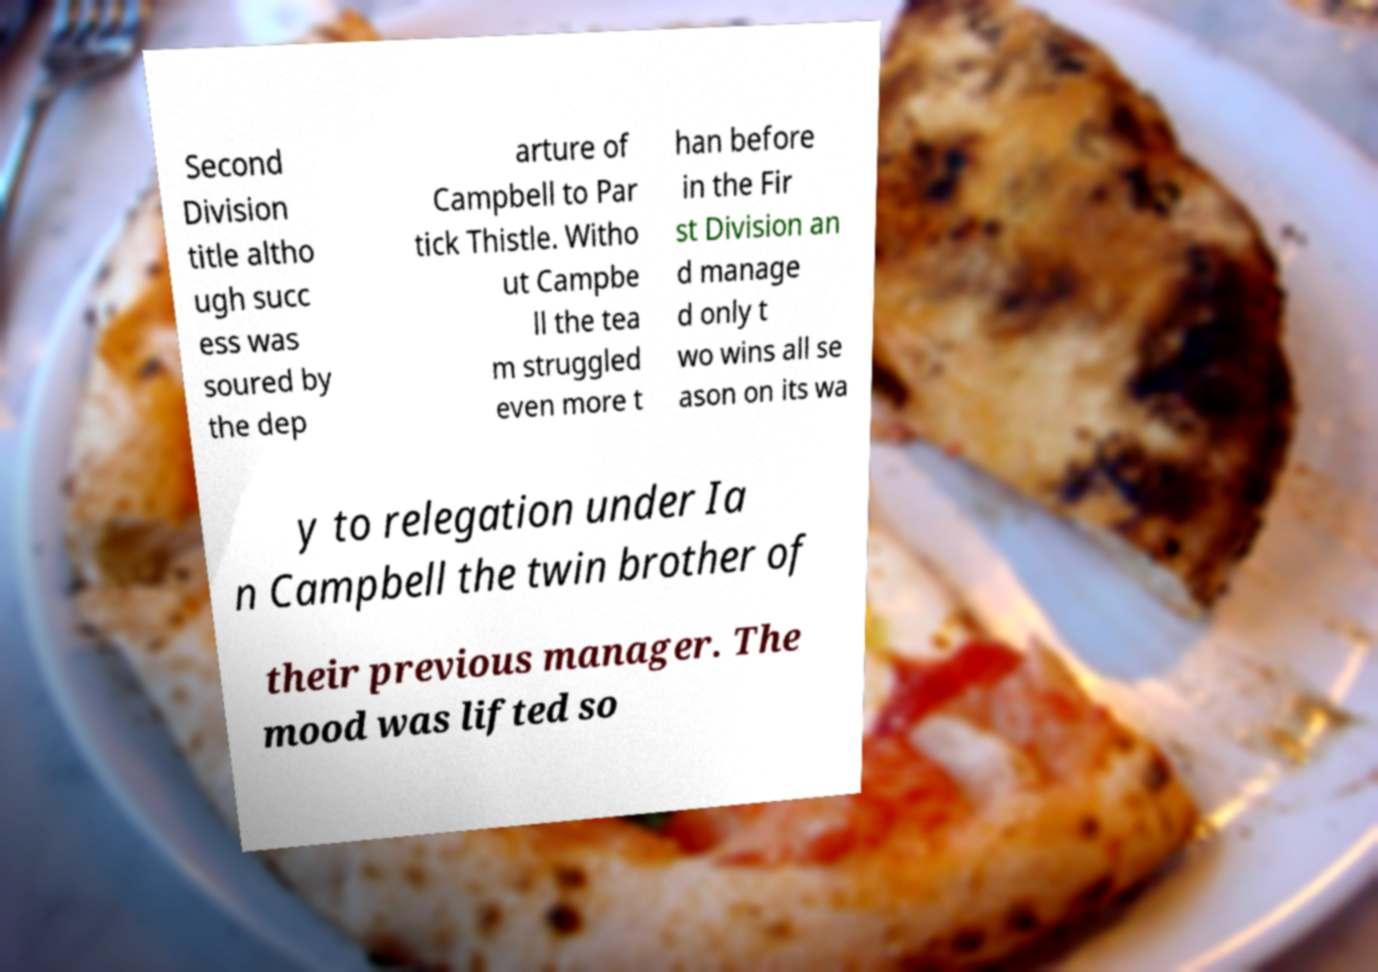There's text embedded in this image that I need extracted. Can you transcribe it verbatim? Second Division title altho ugh succ ess was soured by the dep arture of Campbell to Par tick Thistle. Witho ut Campbe ll the tea m struggled even more t han before in the Fir st Division an d manage d only t wo wins all se ason on its wa y to relegation under Ia n Campbell the twin brother of their previous manager. The mood was lifted so 